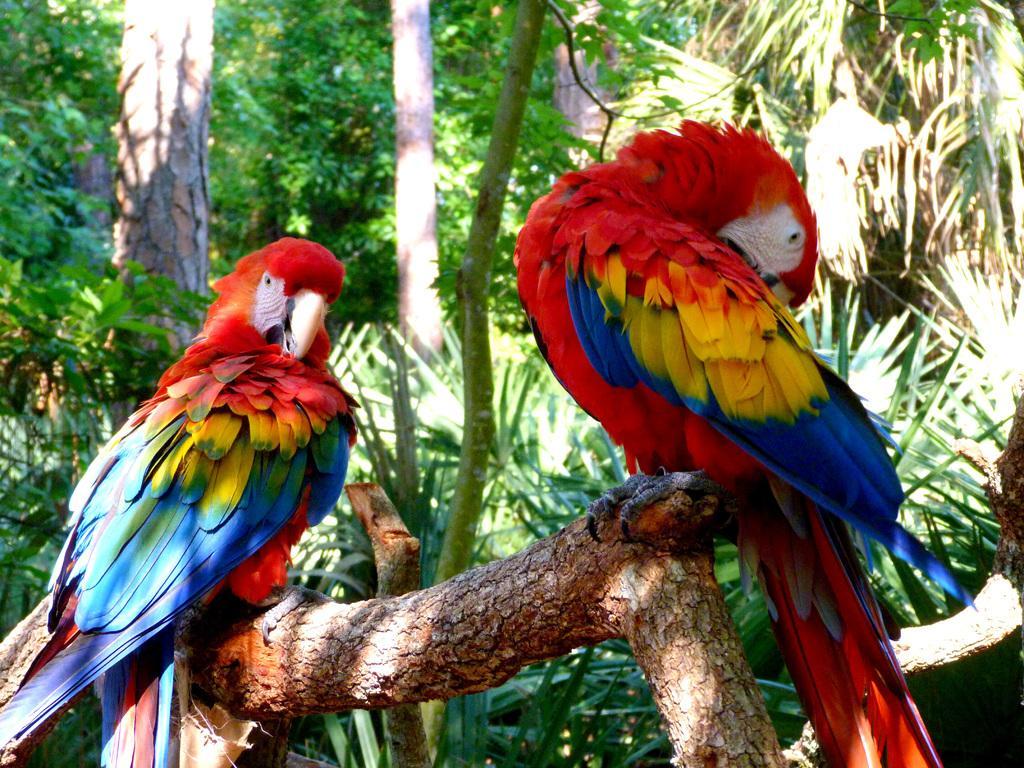Can you describe this image briefly? This picture shows a couple of parrots they are blue, yellow and red in color on the tree branch and we see trees. 